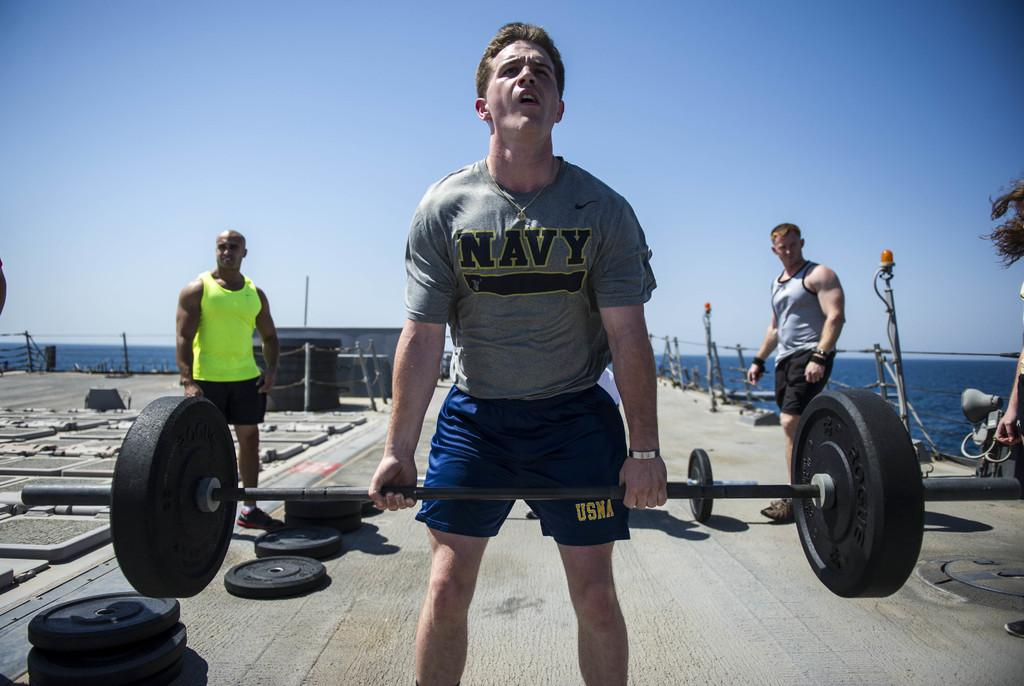<image>
Summarize the visual content of the image. A man lifts weights wearing a top with Navy written on it. 